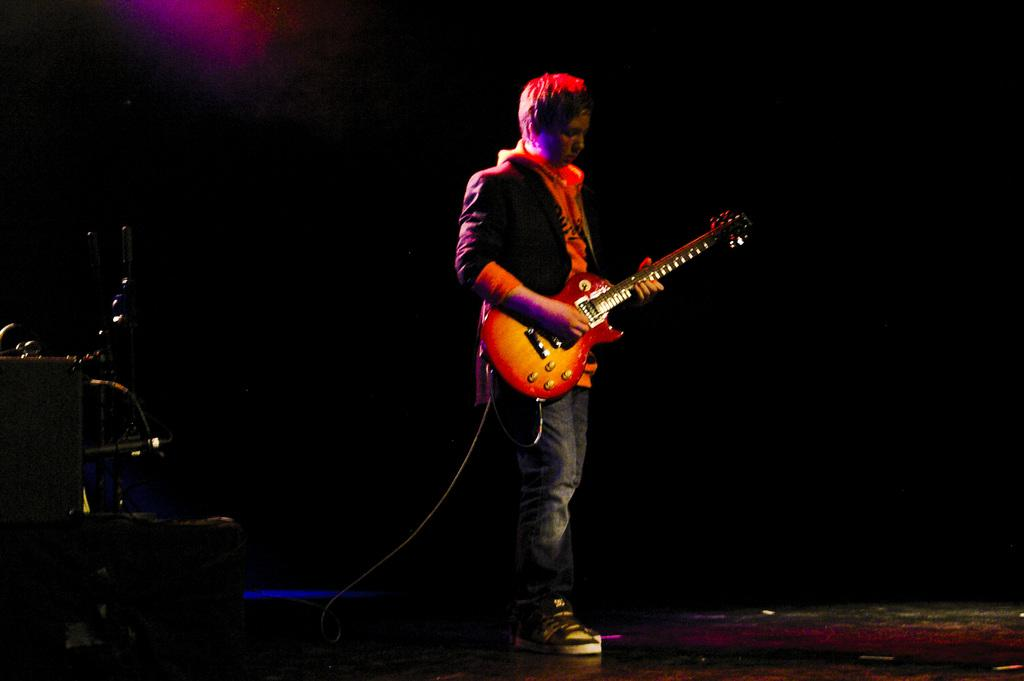What is the main subject of the image? The main subject of the image is a man. What is the man doing in the image? The man is standing in the image. What object is the man holding in the image? The man is holding a guitar in the image. What type of hill can be seen in the background of the image? There is no hill visible in the background of the image. Who is the man's partner in the image? The image does not show the man with a partner. 